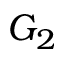Convert formula to latex. <formula><loc_0><loc_0><loc_500><loc_500>G _ { 2 }</formula> 